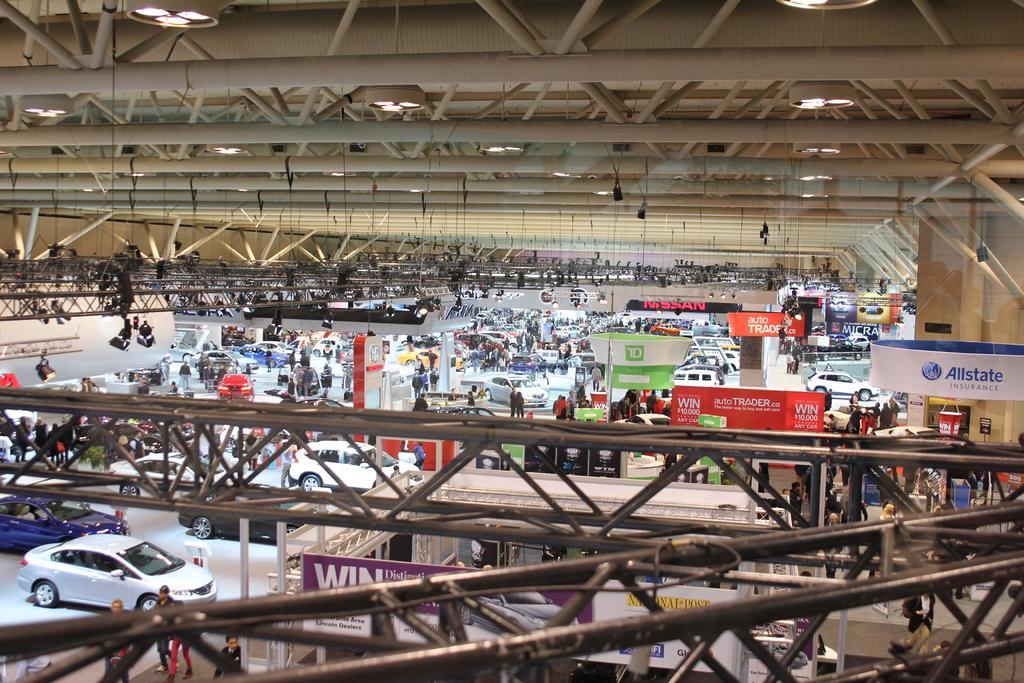Could you give a brief overview of what you see in this image? In the image there are plenty of vehicles and a huge crowd in between those vehicles, there are many banners of different organizations and to the roof there are a lot of iron rods and some lights are fixed to those rods, on the right side there is a Nissan display board, it looks like car expo, there are many new cars in front of each banner. 